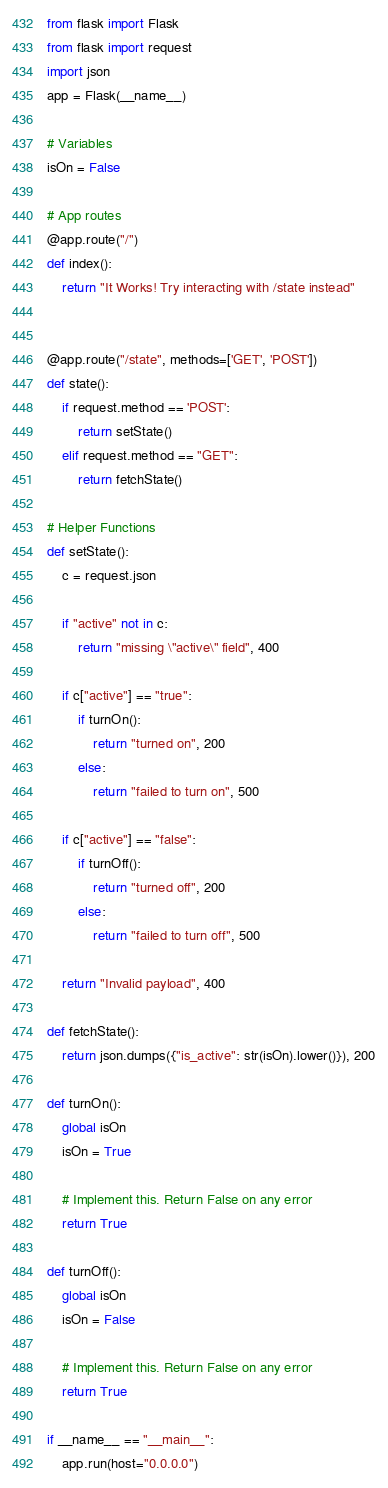Convert code to text. <code><loc_0><loc_0><loc_500><loc_500><_Python_>from flask import Flask
from flask import request
import json
app = Flask(__name__)

# Variables
isOn = False

# App routes
@app.route("/")
def index():
    return "It Works! Try interacting with /state instead"


@app.route("/state", methods=['GET', 'POST'])
def state():
    if request.method == 'POST':
        return setState()
    elif request.method == "GET":
        return fetchState()

# Helper Functions
def setState():
    c = request.json

    if "active" not in c:
        return "missing \"active\" field", 400

    if c["active"] == "true":
        if turnOn():
            return "turned on", 200
        else:
            return "failed to turn on", 500

    if c["active"] == "false":
        if turnOff():
            return "turned off", 200
        else:
            return "failed to turn off", 500

    return "Invalid payload", 400

def fetchState():
    return json.dumps({"is_active": str(isOn).lower()}), 200

def turnOn():
    global isOn
    isOn = True

    # Implement this. Return False on any error
    return True

def turnOff():
    global isOn
    isOn = False

    # Implement this. Return False on any error
    return True

if __name__ == "__main__":
    app.run(host="0.0.0.0")
</code> 